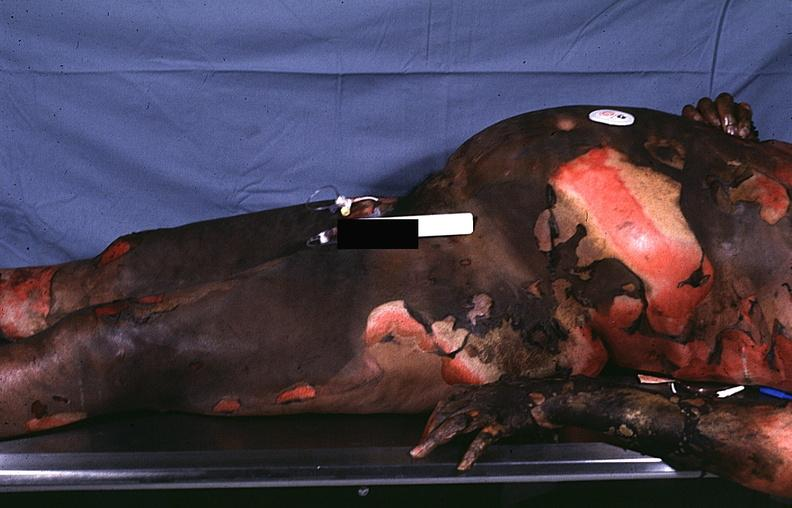does lymphoblastic lymphoma show thermal burn?
Answer the question using a single word or phrase. No 